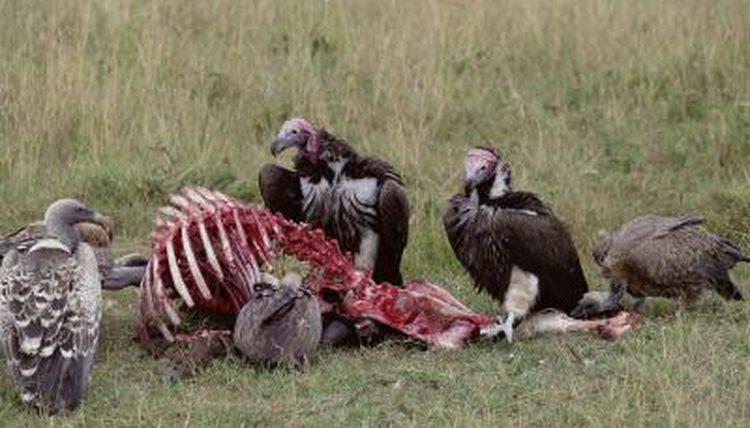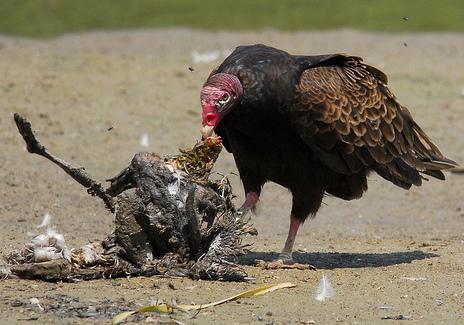The first image is the image on the left, the second image is the image on the right. Assess this claim about the two images: "An image contains only one live vulture, which is standing next to some type of carcass, but not on top of it.". Correct or not? Answer yes or no. Yes. The first image is the image on the left, the second image is the image on the right. Analyze the images presented: Is the assertion "The right image contains no more than one large bird." valid? Answer yes or no. Yes. 